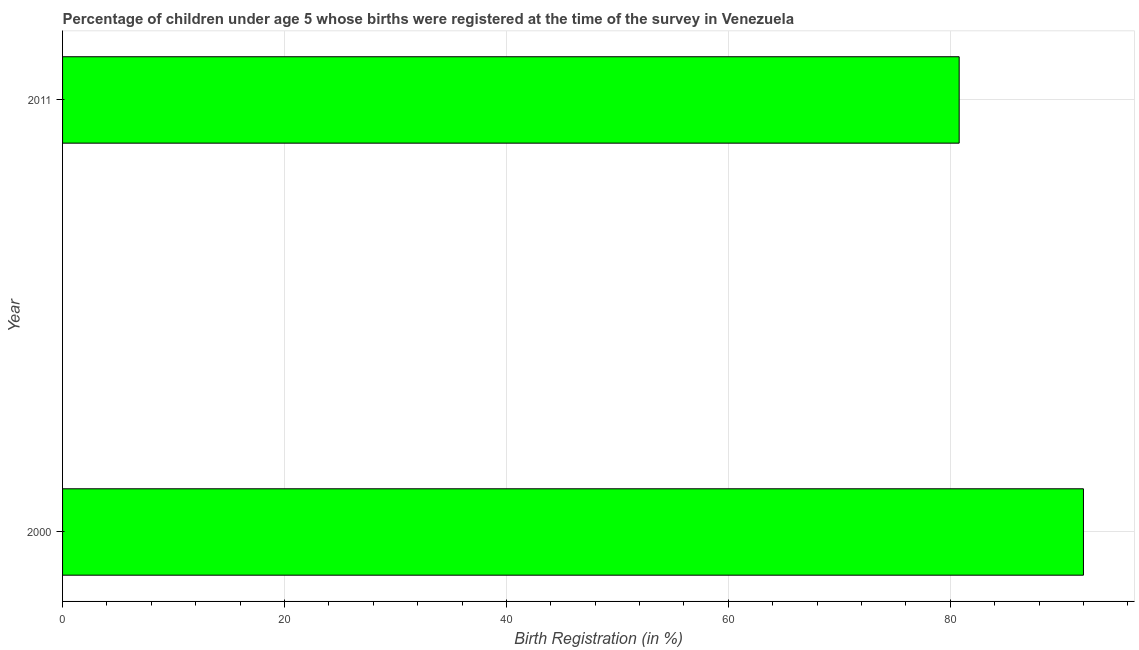Does the graph contain any zero values?
Ensure brevity in your answer.  No. Does the graph contain grids?
Give a very brief answer. Yes. What is the title of the graph?
Keep it short and to the point. Percentage of children under age 5 whose births were registered at the time of the survey in Venezuela. What is the label or title of the X-axis?
Your answer should be compact. Birth Registration (in %). What is the birth registration in 2011?
Provide a short and direct response. 80.8. Across all years, what is the maximum birth registration?
Make the answer very short. 92. Across all years, what is the minimum birth registration?
Your response must be concise. 80.8. In which year was the birth registration maximum?
Keep it short and to the point. 2000. In which year was the birth registration minimum?
Offer a terse response. 2011. What is the sum of the birth registration?
Offer a very short reply. 172.8. What is the average birth registration per year?
Your answer should be very brief. 86.4. What is the median birth registration?
Keep it short and to the point. 86.4. What is the ratio of the birth registration in 2000 to that in 2011?
Provide a succinct answer. 1.14. In how many years, is the birth registration greater than the average birth registration taken over all years?
Your response must be concise. 1. Are all the bars in the graph horizontal?
Give a very brief answer. Yes. What is the difference between two consecutive major ticks on the X-axis?
Your answer should be very brief. 20. Are the values on the major ticks of X-axis written in scientific E-notation?
Offer a very short reply. No. What is the Birth Registration (in %) in 2000?
Provide a succinct answer. 92. What is the Birth Registration (in %) of 2011?
Make the answer very short. 80.8. What is the difference between the Birth Registration (in %) in 2000 and 2011?
Your response must be concise. 11.2. What is the ratio of the Birth Registration (in %) in 2000 to that in 2011?
Your response must be concise. 1.14. 